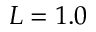Convert formula to latex. <formula><loc_0><loc_0><loc_500><loc_500>L = 1 . 0</formula> 